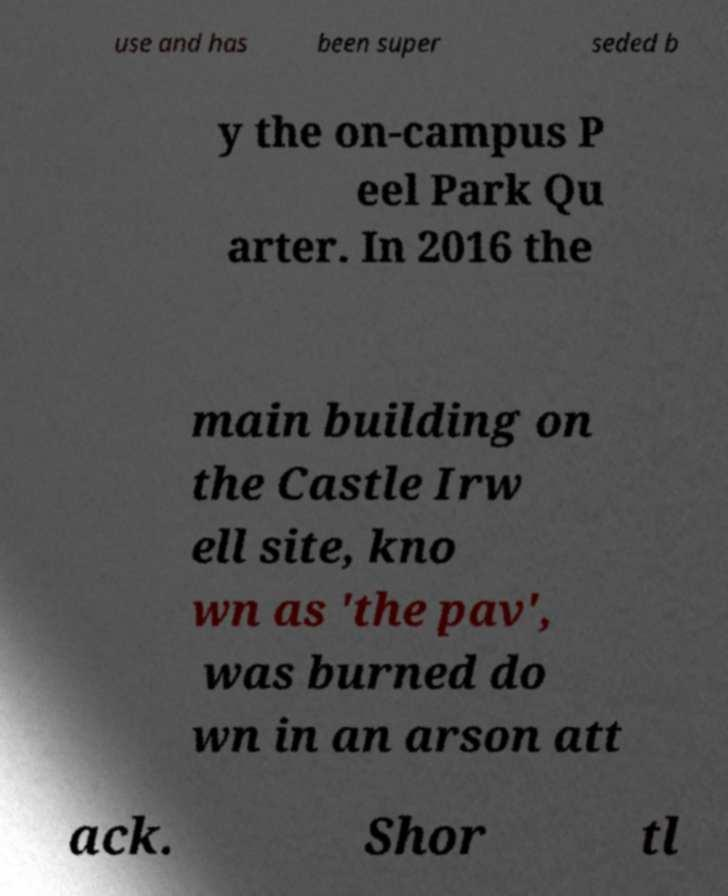Can you accurately transcribe the text from the provided image for me? use and has been super seded b y the on-campus P eel Park Qu arter. In 2016 the main building on the Castle Irw ell site, kno wn as 'the pav', was burned do wn in an arson att ack. Shor tl 